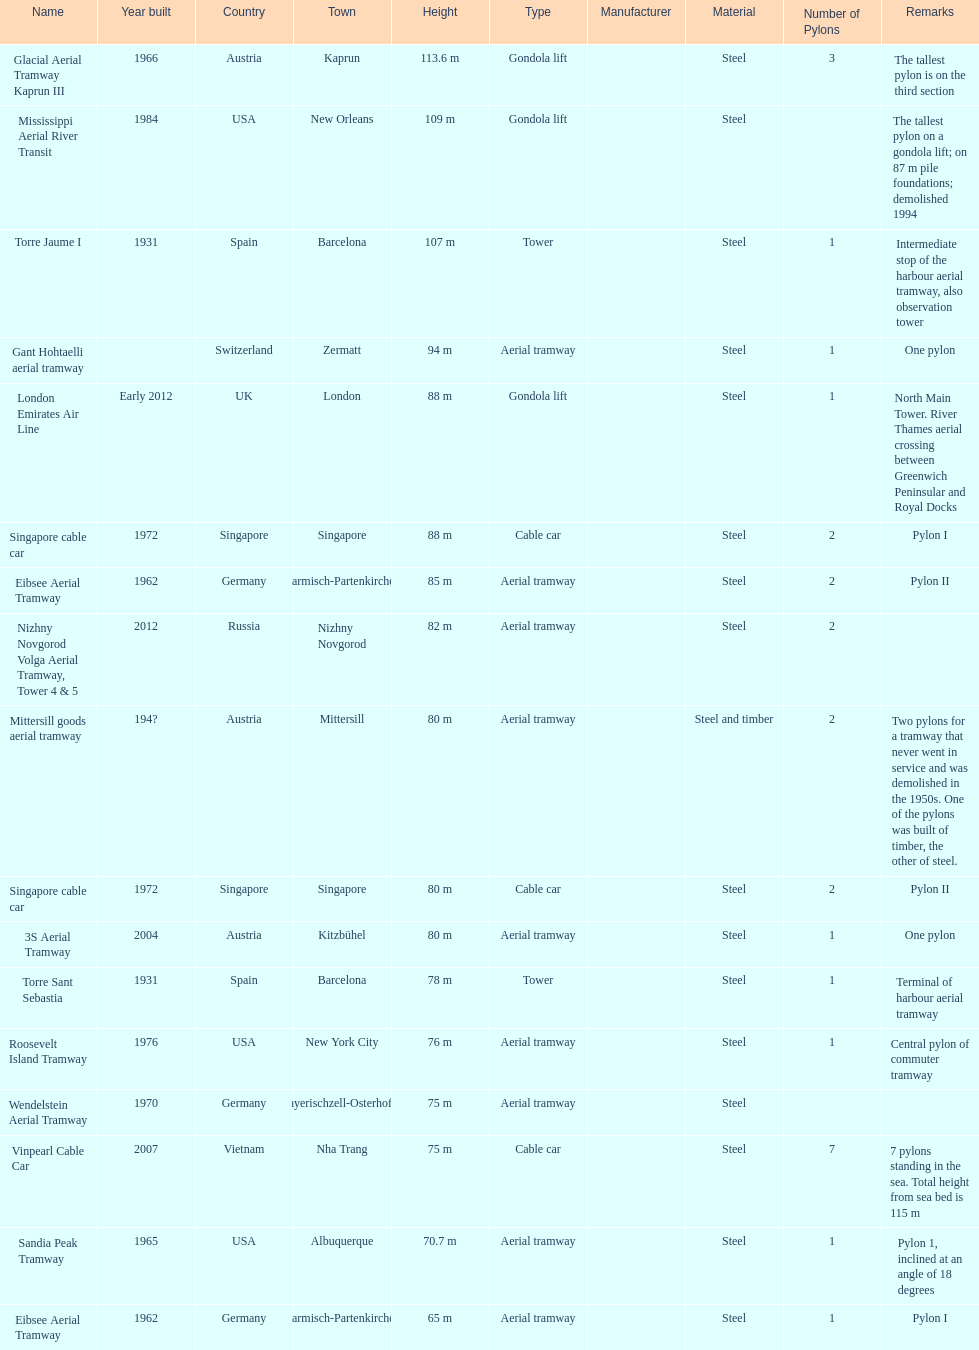How many pylons are in austria? 3. 